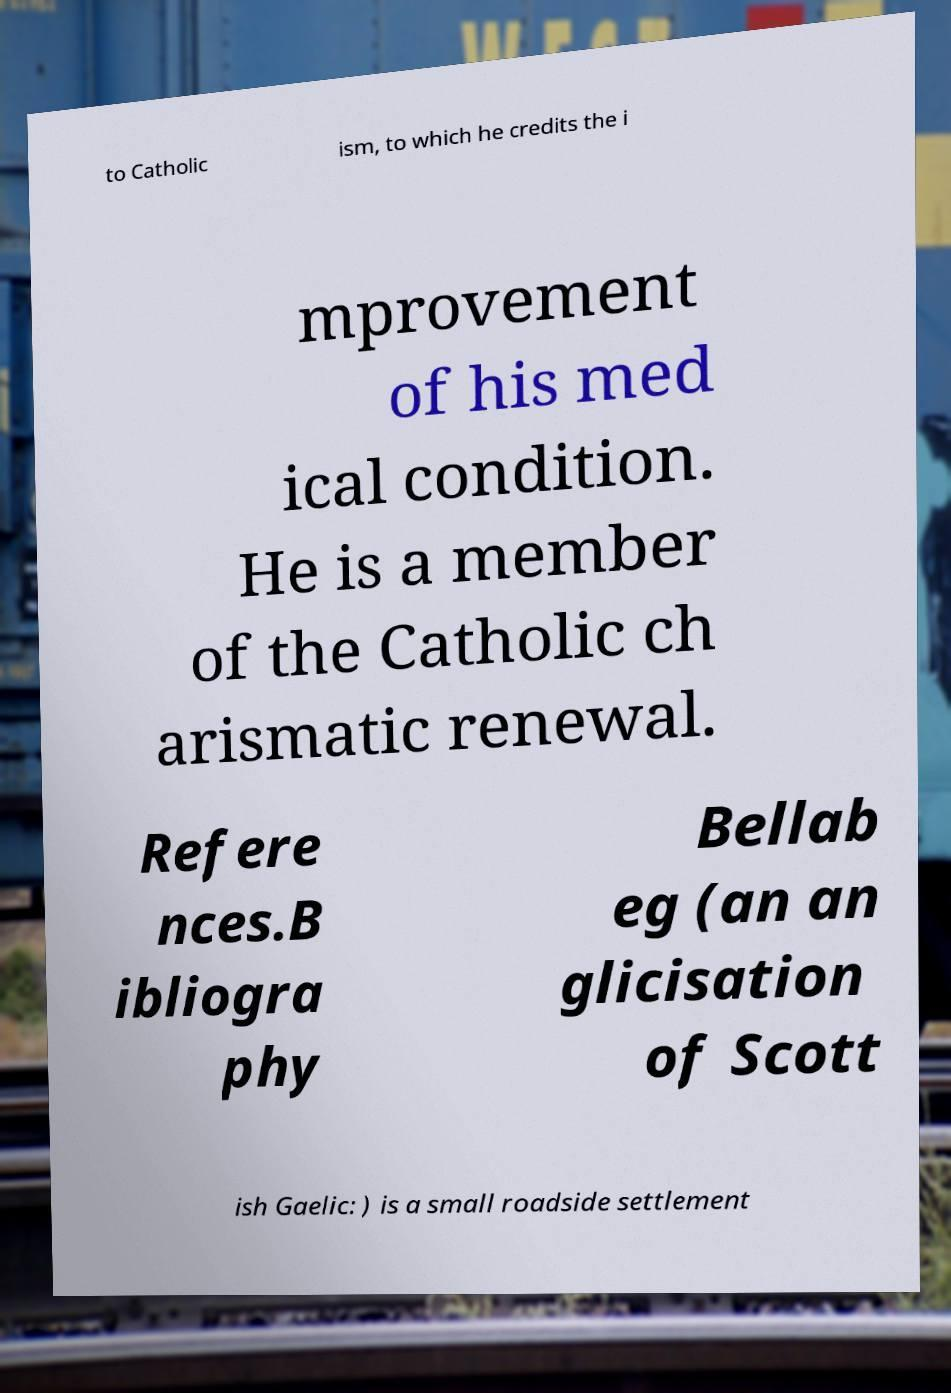Please read and relay the text visible in this image. What does it say? to Catholic ism, to which he credits the i mprovement of his med ical condition. He is a member of the Catholic ch arismatic renewal. Refere nces.B ibliogra phy Bellab eg (an an glicisation of Scott ish Gaelic: ) is a small roadside settlement 